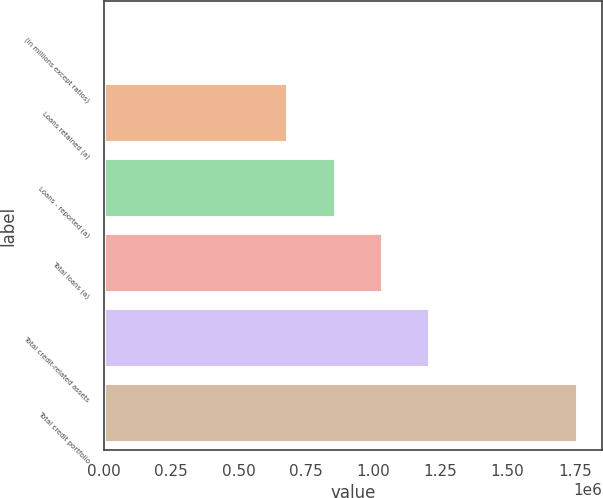Convert chart. <chart><loc_0><loc_0><loc_500><loc_500><bar_chart><fcel>(in millions except ratios)<fcel>Loans retained (a)<fcel>Loans - reported (a)<fcel>Total loans (a)<fcel>Total credit-related assets<fcel>Total credit portfolio<nl><fcel>2010<fcel>685498<fcel>861415<fcel>1.03733e+06<fcel>1.21325e+06<fcel>1.76118e+06<nl></chart> 